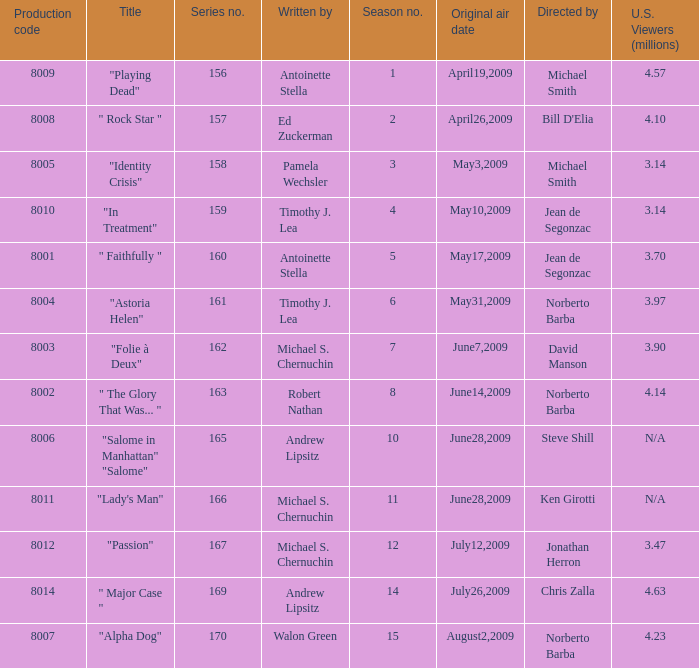Which is the biggest production code? 8014.0. 